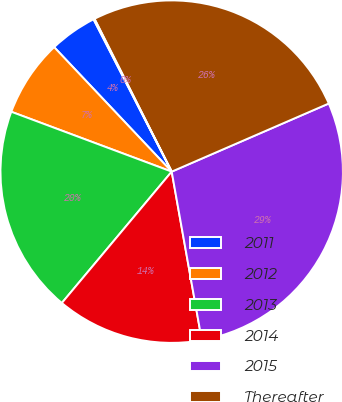Convert chart. <chart><loc_0><loc_0><loc_500><loc_500><pie_chart><fcel>2011<fcel>2012<fcel>2013<fcel>2014<fcel>2015<fcel>Thereafter<fcel>(Discounts) and premiums net<nl><fcel>4.5%<fcel>7.27%<fcel>19.6%<fcel>13.9%<fcel>28.7%<fcel>25.93%<fcel>0.1%<nl></chart> 